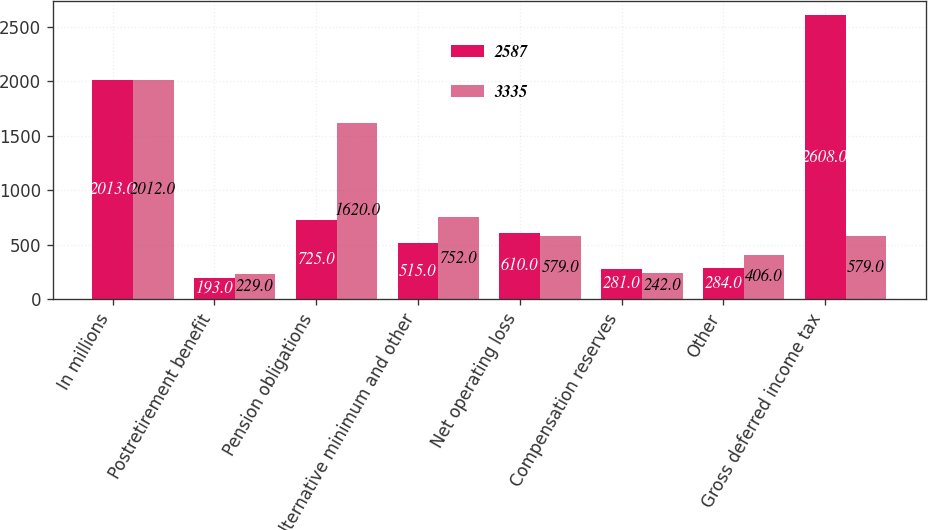<chart> <loc_0><loc_0><loc_500><loc_500><stacked_bar_chart><ecel><fcel>In millions<fcel>Postretirement benefit<fcel>Pension obligations<fcel>Alternative minimum and other<fcel>Net operating loss<fcel>Compensation reserves<fcel>Other<fcel>Gross deferred income tax<nl><fcel>2587<fcel>2013<fcel>193<fcel>725<fcel>515<fcel>610<fcel>281<fcel>284<fcel>2608<nl><fcel>3335<fcel>2012<fcel>229<fcel>1620<fcel>752<fcel>579<fcel>242<fcel>406<fcel>579<nl></chart> 